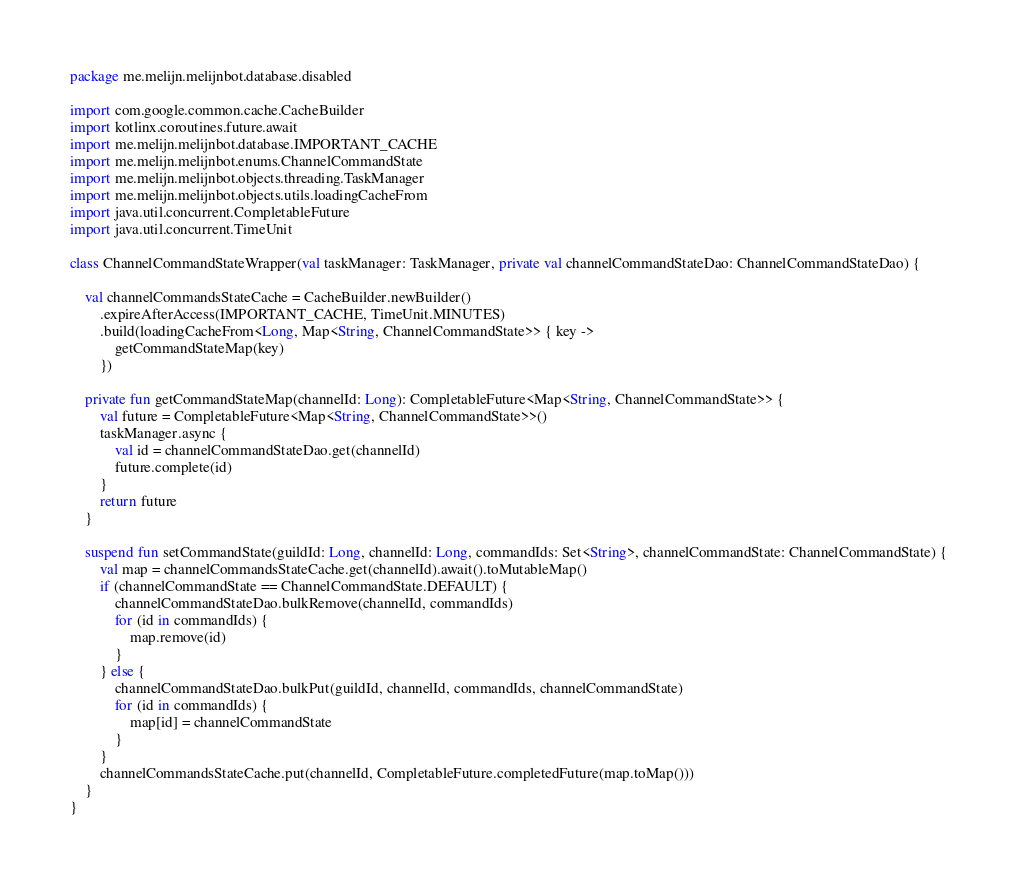Convert code to text. <code><loc_0><loc_0><loc_500><loc_500><_Kotlin_>package me.melijn.melijnbot.database.disabled

import com.google.common.cache.CacheBuilder
import kotlinx.coroutines.future.await
import me.melijn.melijnbot.database.IMPORTANT_CACHE
import me.melijn.melijnbot.enums.ChannelCommandState
import me.melijn.melijnbot.objects.threading.TaskManager
import me.melijn.melijnbot.objects.utils.loadingCacheFrom
import java.util.concurrent.CompletableFuture
import java.util.concurrent.TimeUnit

class ChannelCommandStateWrapper(val taskManager: TaskManager, private val channelCommandStateDao: ChannelCommandStateDao) {

    val channelCommandsStateCache = CacheBuilder.newBuilder()
        .expireAfterAccess(IMPORTANT_CACHE, TimeUnit.MINUTES)
        .build(loadingCacheFrom<Long, Map<String, ChannelCommandState>> { key ->
            getCommandStateMap(key)
        })

    private fun getCommandStateMap(channelId: Long): CompletableFuture<Map<String, ChannelCommandState>> {
        val future = CompletableFuture<Map<String, ChannelCommandState>>()
        taskManager.async {
            val id = channelCommandStateDao.get(channelId)
            future.complete(id)
        }
        return future
    }

    suspend fun setCommandState(guildId: Long, channelId: Long, commandIds: Set<String>, channelCommandState: ChannelCommandState) {
        val map = channelCommandsStateCache.get(channelId).await().toMutableMap()
        if (channelCommandState == ChannelCommandState.DEFAULT) {
            channelCommandStateDao.bulkRemove(channelId, commandIds)
            for (id in commandIds) {
                map.remove(id)
            }
        } else {
            channelCommandStateDao.bulkPut(guildId, channelId, commandIds, channelCommandState)
            for (id in commandIds) {
                map[id] = channelCommandState
            }
        }
        channelCommandsStateCache.put(channelId, CompletableFuture.completedFuture(map.toMap()))
    }
}</code> 